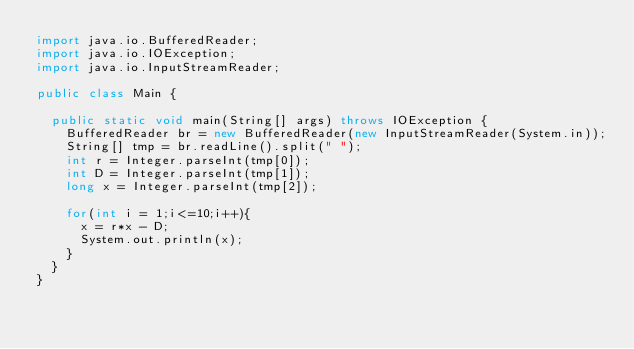<code> <loc_0><loc_0><loc_500><loc_500><_Java_>import java.io.BufferedReader;
import java.io.IOException;
import java.io.InputStreamReader;

public class Main {

	public static void main(String[] args) throws IOException {
		BufferedReader br = new BufferedReader(new InputStreamReader(System.in));
		String[] tmp = br.readLine().split(" ");
		int r = Integer.parseInt(tmp[0]);
		int D = Integer.parseInt(tmp[1]);
		long x = Integer.parseInt(tmp[2]);

		for(int i = 1;i<=10;i++){
			x = r*x - D;
			System.out.println(x);
		}
	}
}
</code> 